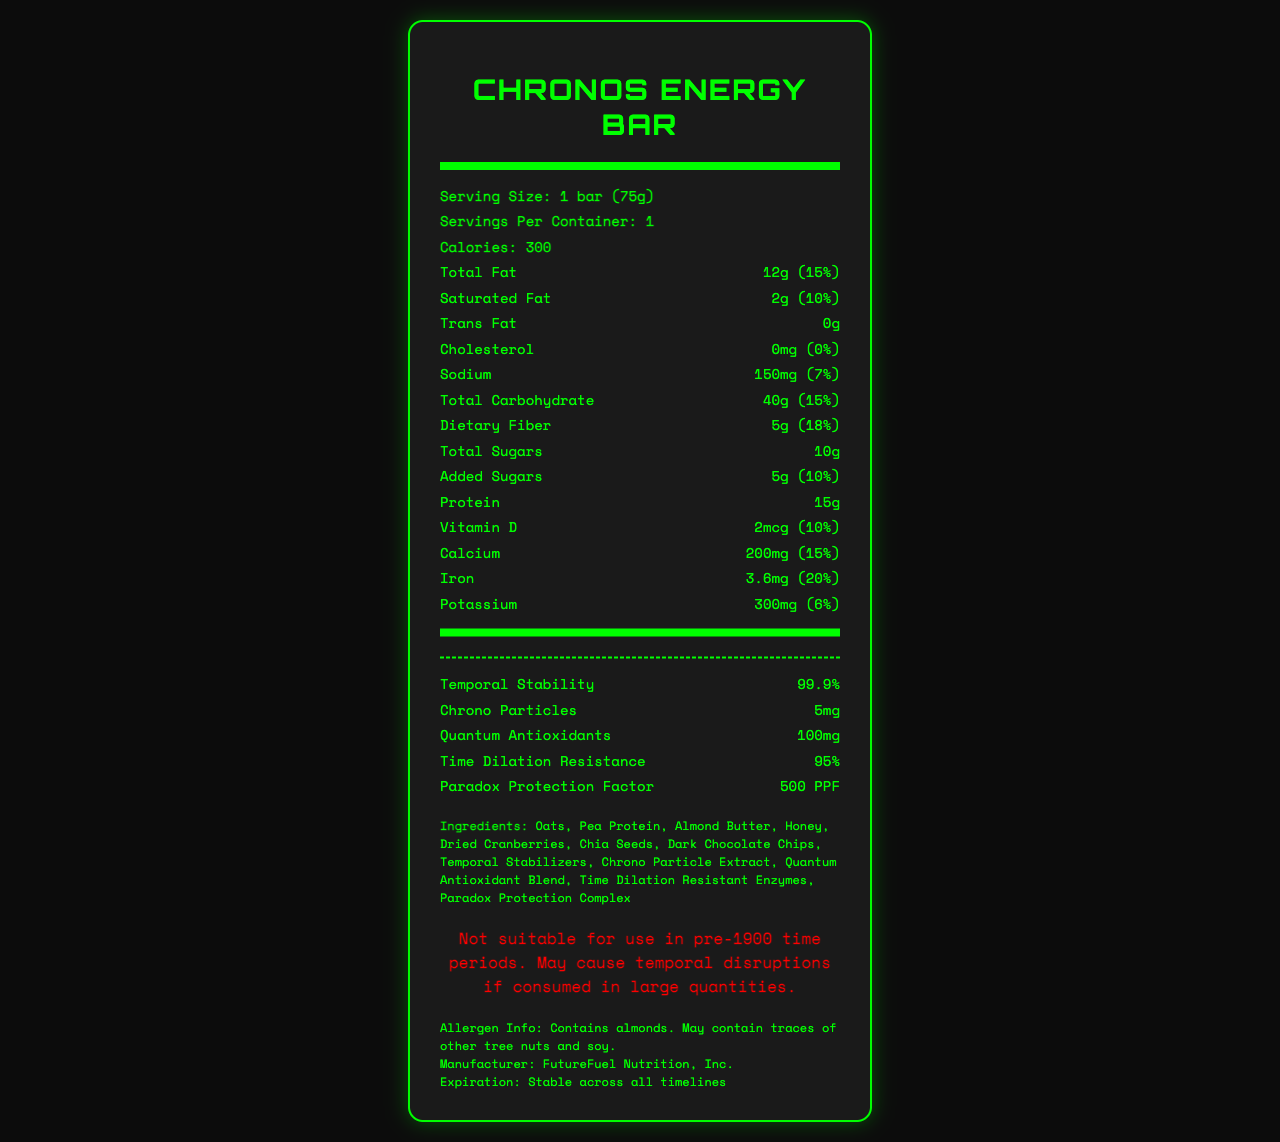what is the serving size of the Chronos Energy Bar? The serving size is clearly stated under the product name as "1 bar (75g)".
Answer: 1 bar (75g) how many calories are in one serving of the Chronos Energy Bar? The calorie count is listed under "Calories" with a value of 300.
Answer: 300 what amount of dietary fiber does the bar contain? The amount of dietary fiber is indicated as "5g" next to "Dietary Fiber".
Answer: 5g what is the paradox protection factor (PPF) of the Chronos Energy Bar? The "Paradox Protection Factor" is listed as "500 PPF".
Answer: 500 PPF what main warning is associated with consuming the Chronos Energy Bar in pre-1900 time periods? The warning specifically states this information.
Answer: May cause temporal disruptions if consumed in large quantities which ingredient in the Chronos Energy Bar could be problematic for someone with tree nut allergies? The allergen info section states "Contains almonds", and almond butter is listed as an ingredient.
Answer: Almond Butter how stable is the Chronos Energy Bar across timelines? The expiration date section mentions "Stable across all timelines".
Answer: Stable across all timelines which of the following nutrients has the highest daily value percentage? A. Calcium B. Iron C. Dietary Fiber D. Saturated Fat Iron has a daily value of 20%, which is the highest among the listed options.
Answer: B. Iron what is the amount of Quantum Antioxidants in the Chronos Energy Bar? 1. 50mg 2. 5mg 3. 100mg 4. 200mg The amount of Quantum Antioxidants is listed as "100mg".
Answer: 3. 100mg does the Chronos Energy Bar contain any trans fat? The trans fat content is listed as "0g", indicating the absence of trans fat.
Answer: No summarize the key nutritional and special components of the Chronos Energy Bar. This summary captures the essential nutritional information and highlights the special features of the Chronos Energy Bar.
Answer: The Chronos Energy Bar provides 300 calories with 15g of protein and various nutrients like vitamins and minerals. It includes unique components suited for time travelers such as temporal stability, chrono particles, quantum antioxidants, time dilation resistance, and a paradox protection factor. It is stable across all timelines but may cause temporal disruptions in pre-1900 periods. how long has FutureFuel Nutrition, Inc. been manufacturing the Chronos Energy Bar? The document does not provide details about the duration of manufacturing for the Chronos Energy Bar by FutureFuel Nutrition, Inc.
Answer: Not enough information 